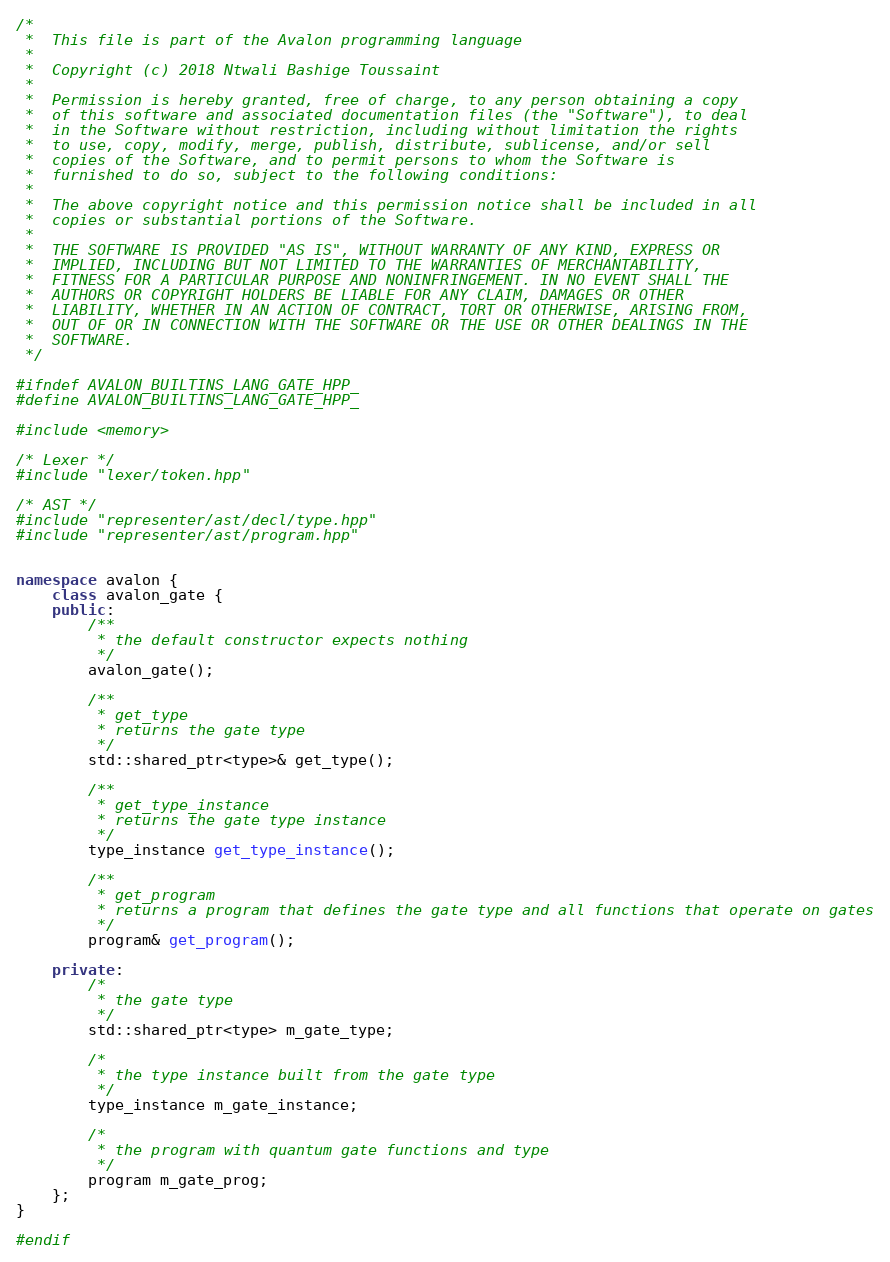<code> <loc_0><loc_0><loc_500><loc_500><_C++_>/*
 *  This file is part of the Avalon programming language
 * 
 *  Copyright (c) 2018 Ntwali Bashige Toussaint
 *
 *  Permission is hereby granted, free of charge, to any person obtaining a copy
 *  of this software and associated documentation files (the "Software"), to deal
 *  in the Software without restriction, including without limitation the rights
 *  to use, copy, modify, merge, publish, distribute, sublicense, and/or sell
 *  copies of the Software, and to permit persons to whom the Software is
 *  furnished to do so, subject to the following conditions:
 *
 *  The above copyright notice and this permission notice shall be included in all
 *  copies or substantial portions of the Software.
 *
 *  THE SOFTWARE IS PROVIDED "AS IS", WITHOUT WARRANTY OF ANY KIND, EXPRESS OR
 *  IMPLIED, INCLUDING BUT NOT LIMITED TO THE WARRANTIES OF MERCHANTABILITY,
 *  FITNESS FOR A PARTICULAR PURPOSE AND NONINFRINGEMENT. IN NO EVENT SHALL THE
 *  AUTHORS OR COPYRIGHT HOLDERS BE LIABLE FOR ANY CLAIM, DAMAGES OR OTHER
 *  LIABILITY, WHETHER IN AN ACTION OF CONTRACT, TORT OR OTHERWISE, ARISING FROM,
 *  OUT OF OR IN CONNECTION WITH THE SOFTWARE OR THE USE OR OTHER DEALINGS IN THE
 *  SOFTWARE.
 */

#ifndef AVALON_BUILTINS_LANG_GATE_HPP_
#define AVALON_BUILTINS_LANG_GATE_HPP_

#include <memory>

/* Lexer */
#include "lexer/token.hpp"

/* AST */
#include "representer/ast/decl/type.hpp"
#include "representer/ast/program.hpp"


namespace avalon {
    class avalon_gate {
    public:
        /**
         * the default constructor expects nothing
         */
        avalon_gate();

        /**
         * get_type
         * returns the gate type
         */
        std::shared_ptr<type>& get_type();

        /**
         * get_type_instance
         * returns the gate type instance
         */
        type_instance get_type_instance();

        /**
         * get_program
         * returns a program that defines the gate type and all functions that operate on gates
         */
        program& get_program();

    private:
        /*
         * the gate type
         */
        std::shared_ptr<type> m_gate_type;

        /*
         * the type instance built from the gate type
         */
        type_instance m_gate_instance;

        /*
         * the program with quantum gate functions and type
         */
        program m_gate_prog;
    };
}

#endif
</code> 